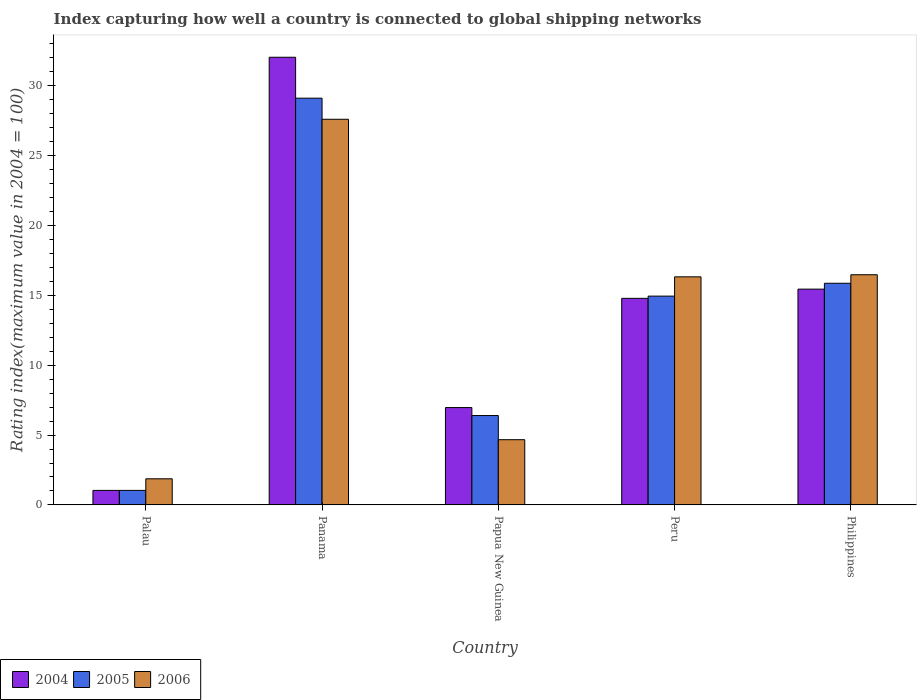How many different coloured bars are there?
Your answer should be compact. 3. How many groups of bars are there?
Give a very brief answer. 5. Are the number of bars per tick equal to the number of legend labels?
Give a very brief answer. Yes. How many bars are there on the 5th tick from the left?
Provide a short and direct response. 3. What is the label of the 1st group of bars from the left?
Provide a short and direct response. Palau. What is the rating index in 2004 in Papua New Guinea?
Make the answer very short. 6.97. Across all countries, what is the maximum rating index in 2005?
Ensure brevity in your answer.  29.12. In which country was the rating index in 2005 maximum?
Your answer should be very brief. Panama. In which country was the rating index in 2004 minimum?
Give a very brief answer. Palau. What is the total rating index in 2006 in the graph?
Give a very brief answer. 66.96. What is the difference between the rating index in 2005 in Papua New Guinea and that in Peru?
Offer a very short reply. -8.55. What is the difference between the rating index in 2005 in Panama and the rating index in 2006 in Papua New Guinea?
Ensure brevity in your answer.  24.45. What is the average rating index in 2006 per country?
Offer a very short reply. 13.39. What is the difference between the rating index of/in 2004 and rating index of/in 2005 in Philippines?
Provide a succinct answer. -0.42. What is the ratio of the rating index in 2006 in Peru to that in Philippines?
Your response must be concise. 0.99. Is the difference between the rating index in 2004 in Papua New Guinea and Philippines greater than the difference between the rating index in 2005 in Papua New Guinea and Philippines?
Give a very brief answer. Yes. What is the difference between the highest and the second highest rating index in 2006?
Provide a succinct answer. 0.15. What is the difference between the highest and the lowest rating index in 2006?
Ensure brevity in your answer.  25.74. Is the sum of the rating index in 2005 in Palau and Peru greater than the maximum rating index in 2004 across all countries?
Make the answer very short. No. What does the 3rd bar from the right in Palau represents?
Give a very brief answer. 2004. What is the difference between two consecutive major ticks on the Y-axis?
Offer a very short reply. 5. Does the graph contain grids?
Offer a terse response. No. How are the legend labels stacked?
Give a very brief answer. Horizontal. What is the title of the graph?
Provide a succinct answer. Index capturing how well a country is connected to global shipping networks. Does "1986" appear as one of the legend labels in the graph?
Your response must be concise. No. What is the label or title of the Y-axis?
Give a very brief answer. Rating index(maximum value in 2004 = 100). What is the Rating index(maximum value in 2004 = 100) in 2004 in Palau?
Offer a very short reply. 1.04. What is the Rating index(maximum value in 2004 = 100) of 2005 in Palau?
Keep it short and to the point. 1.04. What is the Rating index(maximum value in 2004 = 100) of 2006 in Palau?
Keep it short and to the point. 1.87. What is the Rating index(maximum value in 2004 = 100) of 2004 in Panama?
Keep it short and to the point. 32.05. What is the Rating index(maximum value in 2004 = 100) of 2005 in Panama?
Ensure brevity in your answer.  29.12. What is the Rating index(maximum value in 2004 = 100) in 2006 in Panama?
Ensure brevity in your answer.  27.61. What is the Rating index(maximum value in 2004 = 100) of 2004 in Papua New Guinea?
Ensure brevity in your answer.  6.97. What is the Rating index(maximum value in 2004 = 100) of 2006 in Papua New Guinea?
Your answer should be very brief. 4.67. What is the Rating index(maximum value in 2004 = 100) in 2004 in Peru?
Provide a short and direct response. 14.79. What is the Rating index(maximum value in 2004 = 100) in 2005 in Peru?
Provide a short and direct response. 14.95. What is the Rating index(maximum value in 2004 = 100) in 2006 in Peru?
Make the answer very short. 16.33. What is the Rating index(maximum value in 2004 = 100) of 2004 in Philippines?
Your answer should be compact. 15.45. What is the Rating index(maximum value in 2004 = 100) of 2005 in Philippines?
Make the answer very short. 15.87. What is the Rating index(maximum value in 2004 = 100) in 2006 in Philippines?
Offer a very short reply. 16.48. Across all countries, what is the maximum Rating index(maximum value in 2004 = 100) of 2004?
Your answer should be compact. 32.05. Across all countries, what is the maximum Rating index(maximum value in 2004 = 100) of 2005?
Ensure brevity in your answer.  29.12. Across all countries, what is the maximum Rating index(maximum value in 2004 = 100) in 2006?
Make the answer very short. 27.61. Across all countries, what is the minimum Rating index(maximum value in 2004 = 100) in 2004?
Ensure brevity in your answer.  1.04. Across all countries, what is the minimum Rating index(maximum value in 2004 = 100) of 2005?
Offer a very short reply. 1.04. Across all countries, what is the minimum Rating index(maximum value in 2004 = 100) in 2006?
Ensure brevity in your answer.  1.87. What is the total Rating index(maximum value in 2004 = 100) in 2004 in the graph?
Provide a succinct answer. 70.3. What is the total Rating index(maximum value in 2004 = 100) in 2005 in the graph?
Your answer should be very brief. 67.38. What is the total Rating index(maximum value in 2004 = 100) of 2006 in the graph?
Your answer should be very brief. 66.96. What is the difference between the Rating index(maximum value in 2004 = 100) in 2004 in Palau and that in Panama?
Ensure brevity in your answer.  -31.01. What is the difference between the Rating index(maximum value in 2004 = 100) of 2005 in Palau and that in Panama?
Offer a very short reply. -28.08. What is the difference between the Rating index(maximum value in 2004 = 100) of 2006 in Palau and that in Panama?
Provide a short and direct response. -25.74. What is the difference between the Rating index(maximum value in 2004 = 100) in 2004 in Palau and that in Papua New Guinea?
Offer a very short reply. -5.93. What is the difference between the Rating index(maximum value in 2004 = 100) in 2005 in Palau and that in Papua New Guinea?
Your response must be concise. -5.36. What is the difference between the Rating index(maximum value in 2004 = 100) of 2006 in Palau and that in Papua New Guinea?
Give a very brief answer. -2.8. What is the difference between the Rating index(maximum value in 2004 = 100) in 2004 in Palau and that in Peru?
Provide a short and direct response. -13.75. What is the difference between the Rating index(maximum value in 2004 = 100) of 2005 in Palau and that in Peru?
Ensure brevity in your answer.  -13.91. What is the difference between the Rating index(maximum value in 2004 = 100) in 2006 in Palau and that in Peru?
Offer a very short reply. -14.46. What is the difference between the Rating index(maximum value in 2004 = 100) of 2004 in Palau and that in Philippines?
Ensure brevity in your answer.  -14.41. What is the difference between the Rating index(maximum value in 2004 = 100) of 2005 in Palau and that in Philippines?
Provide a succinct answer. -14.83. What is the difference between the Rating index(maximum value in 2004 = 100) in 2006 in Palau and that in Philippines?
Provide a succinct answer. -14.61. What is the difference between the Rating index(maximum value in 2004 = 100) in 2004 in Panama and that in Papua New Guinea?
Provide a succinct answer. 25.08. What is the difference between the Rating index(maximum value in 2004 = 100) in 2005 in Panama and that in Papua New Guinea?
Offer a very short reply. 22.72. What is the difference between the Rating index(maximum value in 2004 = 100) of 2006 in Panama and that in Papua New Guinea?
Provide a short and direct response. 22.94. What is the difference between the Rating index(maximum value in 2004 = 100) in 2004 in Panama and that in Peru?
Your answer should be compact. 17.26. What is the difference between the Rating index(maximum value in 2004 = 100) in 2005 in Panama and that in Peru?
Offer a very short reply. 14.17. What is the difference between the Rating index(maximum value in 2004 = 100) of 2006 in Panama and that in Peru?
Your answer should be compact. 11.28. What is the difference between the Rating index(maximum value in 2004 = 100) of 2004 in Panama and that in Philippines?
Make the answer very short. 16.6. What is the difference between the Rating index(maximum value in 2004 = 100) of 2005 in Panama and that in Philippines?
Ensure brevity in your answer.  13.25. What is the difference between the Rating index(maximum value in 2004 = 100) in 2006 in Panama and that in Philippines?
Offer a very short reply. 11.13. What is the difference between the Rating index(maximum value in 2004 = 100) of 2004 in Papua New Guinea and that in Peru?
Ensure brevity in your answer.  -7.82. What is the difference between the Rating index(maximum value in 2004 = 100) in 2005 in Papua New Guinea and that in Peru?
Your answer should be very brief. -8.55. What is the difference between the Rating index(maximum value in 2004 = 100) in 2006 in Papua New Guinea and that in Peru?
Your answer should be very brief. -11.66. What is the difference between the Rating index(maximum value in 2004 = 100) in 2004 in Papua New Guinea and that in Philippines?
Your answer should be compact. -8.48. What is the difference between the Rating index(maximum value in 2004 = 100) in 2005 in Papua New Guinea and that in Philippines?
Keep it short and to the point. -9.47. What is the difference between the Rating index(maximum value in 2004 = 100) of 2006 in Papua New Guinea and that in Philippines?
Give a very brief answer. -11.81. What is the difference between the Rating index(maximum value in 2004 = 100) in 2004 in Peru and that in Philippines?
Make the answer very short. -0.66. What is the difference between the Rating index(maximum value in 2004 = 100) of 2005 in Peru and that in Philippines?
Offer a very short reply. -0.92. What is the difference between the Rating index(maximum value in 2004 = 100) of 2006 in Peru and that in Philippines?
Your response must be concise. -0.15. What is the difference between the Rating index(maximum value in 2004 = 100) of 2004 in Palau and the Rating index(maximum value in 2004 = 100) of 2005 in Panama?
Offer a very short reply. -28.08. What is the difference between the Rating index(maximum value in 2004 = 100) of 2004 in Palau and the Rating index(maximum value in 2004 = 100) of 2006 in Panama?
Your response must be concise. -26.57. What is the difference between the Rating index(maximum value in 2004 = 100) in 2005 in Palau and the Rating index(maximum value in 2004 = 100) in 2006 in Panama?
Your answer should be compact. -26.57. What is the difference between the Rating index(maximum value in 2004 = 100) of 2004 in Palau and the Rating index(maximum value in 2004 = 100) of 2005 in Papua New Guinea?
Keep it short and to the point. -5.36. What is the difference between the Rating index(maximum value in 2004 = 100) in 2004 in Palau and the Rating index(maximum value in 2004 = 100) in 2006 in Papua New Guinea?
Make the answer very short. -3.63. What is the difference between the Rating index(maximum value in 2004 = 100) of 2005 in Palau and the Rating index(maximum value in 2004 = 100) of 2006 in Papua New Guinea?
Your answer should be compact. -3.63. What is the difference between the Rating index(maximum value in 2004 = 100) in 2004 in Palau and the Rating index(maximum value in 2004 = 100) in 2005 in Peru?
Your answer should be compact. -13.91. What is the difference between the Rating index(maximum value in 2004 = 100) of 2004 in Palau and the Rating index(maximum value in 2004 = 100) of 2006 in Peru?
Offer a very short reply. -15.29. What is the difference between the Rating index(maximum value in 2004 = 100) in 2005 in Palau and the Rating index(maximum value in 2004 = 100) in 2006 in Peru?
Make the answer very short. -15.29. What is the difference between the Rating index(maximum value in 2004 = 100) in 2004 in Palau and the Rating index(maximum value in 2004 = 100) in 2005 in Philippines?
Provide a succinct answer. -14.83. What is the difference between the Rating index(maximum value in 2004 = 100) of 2004 in Palau and the Rating index(maximum value in 2004 = 100) of 2006 in Philippines?
Offer a terse response. -15.44. What is the difference between the Rating index(maximum value in 2004 = 100) of 2005 in Palau and the Rating index(maximum value in 2004 = 100) of 2006 in Philippines?
Your response must be concise. -15.44. What is the difference between the Rating index(maximum value in 2004 = 100) of 2004 in Panama and the Rating index(maximum value in 2004 = 100) of 2005 in Papua New Guinea?
Your response must be concise. 25.65. What is the difference between the Rating index(maximum value in 2004 = 100) in 2004 in Panama and the Rating index(maximum value in 2004 = 100) in 2006 in Papua New Guinea?
Your answer should be very brief. 27.38. What is the difference between the Rating index(maximum value in 2004 = 100) of 2005 in Panama and the Rating index(maximum value in 2004 = 100) of 2006 in Papua New Guinea?
Provide a succinct answer. 24.45. What is the difference between the Rating index(maximum value in 2004 = 100) of 2004 in Panama and the Rating index(maximum value in 2004 = 100) of 2005 in Peru?
Your answer should be very brief. 17.1. What is the difference between the Rating index(maximum value in 2004 = 100) in 2004 in Panama and the Rating index(maximum value in 2004 = 100) in 2006 in Peru?
Your response must be concise. 15.72. What is the difference between the Rating index(maximum value in 2004 = 100) of 2005 in Panama and the Rating index(maximum value in 2004 = 100) of 2006 in Peru?
Offer a terse response. 12.79. What is the difference between the Rating index(maximum value in 2004 = 100) in 2004 in Panama and the Rating index(maximum value in 2004 = 100) in 2005 in Philippines?
Make the answer very short. 16.18. What is the difference between the Rating index(maximum value in 2004 = 100) in 2004 in Panama and the Rating index(maximum value in 2004 = 100) in 2006 in Philippines?
Give a very brief answer. 15.57. What is the difference between the Rating index(maximum value in 2004 = 100) of 2005 in Panama and the Rating index(maximum value in 2004 = 100) of 2006 in Philippines?
Your answer should be compact. 12.64. What is the difference between the Rating index(maximum value in 2004 = 100) of 2004 in Papua New Guinea and the Rating index(maximum value in 2004 = 100) of 2005 in Peru?
Offer a very short reply. -7.98. What is the difference between the Rating index(maximum value in 2004 = 100) of 2004 in Papua New Guinea and the Rating index(maximum value in 2004 = 100) of 2006 in Peru?
Your response must be concise. -9.36. What is the difference between the Rating index(maximum value in 2004 = 100) of 2005 in Papua New Guinea and the Rating index(maximum value in 2004 = 100) of 2006 in Peru?
Make the answer very short. -9.93. What is the difference between the Rating index(maximum value in 2004 = 100) in 2004 in Papua New Guinea and the Rating index(maximum value in 2004 = 100) in 2006 in Philippines?
Your response must be concise. -9.51. What is the difference between the Rating index(maximum value in 2004 = 100) of 2005 in Papua New Guinea and the Rating index(maximum value in 2004 = 100) of 2006 in Philippines?
Give a very brief answer. -10.08. What is the difference between the Rating index(maximum value in 2004 = 100) of 2004 in Peru and the Rating index(maximum value in 2004 = 100) of 2005 in Philippines?
Provide a short and direct response. -1.08. What is the difference between the Rating index(maximum value in 2004 = 100) of 2004 in Peru and the Rating index(maximum value in 2004 = 100) of 2006 in Philippines?
Provide a short and direct response. -1.69. What is the difference between the Rating index(maximum value in 2004 = 100) of 2005 in Peru and the Rating index(maximum value in 2004 = 100) of 2006 in Philippines?
Provide a succinct answer. -1.53. What is the average Rating index(maximum value in 2004 = 100) in 2004 per country?
Provide a short and direct response. 14.06. What is the average Rating index(maximum value in 2004 = 100) of 2005 per country?
Keep it short and to the point. 13.48. What is the average Rating index(maximum value in 2004 = 100) of 2006 per country?
Keep it short and to the point. 13.39. What is the difference between the Rating index(maximum value in 2004 = 100) in 2004 and Rating index(maximum value in 2004 = 100) in 2006 in Palau?
Offer a terse response. -0.83. What is the difference between the Rating index(maximum value in 2004 = 100) in 2005 and Rating index(maximum value in 2004 = 100) in 2006 in Palau?
Your answer should be very brief. -0.83. What is the difference between the Rating index(maximum value in 2004 = 100) of 2004 and Rating index(maximum value in 2004 = 100) of 2005 in Panama?
Give a very brief answer. 2.93. What is the difference between the Rating index(maximum value in 2004 = 100) in 2004 and Rating index(maximum value in 2004 = 100) in 2006 in Panama?
Provide a short and direct response. 4.44. What is the difference between the Rating index(maximum value in 2004 = 100) in 2005 and Rating index(maximum value in 2004 = 100) in 2006 in Panama?
Offer a very short reply. 1.51. What is the difference between the Rating index(maximum value in 2004 = 100) of 2004 and Rating index(maximum value in 2004 = 100) of 2005 in Papua New Guinea?
Provide a succinct answer. 0.57. What is the difference between the Rating index(maximum value in 2004 = 100) in 2005 and Rating index(maximum value in 2004 = 100) in 2006 in Papua New Guinea?
Ensure brevity in your answer.  1.73. What is the difference between the Rating index(maximum value in 2004 = 100) of 2004 and Rating index(maximum value in 2004 = 100) of 2005 in Peru?
Your answer should be very brief. -0.16. What is the difference between the Rating index(maximum value in 2004 = 100) in 2004 and Rating index(maximum value in 2004 = 100) in 2006 in Peru?
Ensure brevity in your answer.  -1.54. What is the difference between the Rating index(maximum value in 2004 = 100) of 2005 and Rating index(maximum value in 2004 = 100) of 2006 in Peru?
Your answer should be compact. -1.38. What is the difference between the Rating index(maximum value in 2004 = 100) in 2004 and Rating index(maximum value in 2004 = 100) in 2005 in Philippines?
Make the answer very short. -0.42. What is the difference between the Rating index(maximum value in 2004 = 100) of 2004 and Rating index(maximum value in 2004 = 100) of 2006 in Philippines?
Offer a terse response. -1.03. What is the difference between the Rating index(maximum value in 2004 = 100) in 2005 and Rating index(maximum value in 2004 = 100) in 2006 in Philippines?
Provide a succinct answer. -0.61. What is the ratio of the Rating index(maximum value in 2004 = 100) of 2004 in Palau to that in Panama?
Offer a very short reply. 0.03. What is the ratio of the Rating index(maximum value in 2004 = 100) of 2005 in Palau to that in Panama?
Your answer should be compact. 0.04. What is the ratio of the Rating index(maximum value in 2004 = 100) of 2006 in Palau to that in Panama?
Provide a succinct answer. 0.07. What is the ratio of the Rating index(maximum value in 2004 = 100) in 2004 in Palau to that in Papua New Guinea?
Your answer should be compact. 0.15. What is the ratio of the Rating index(maximum value in 2004 = 100) of 2005 in Palau to that in Papua New Guinea?
Your answer should be compact. 0.16. What is the ratio of the Rating index(maximum value in 2004 = 100) in 2006 in Palau to that in Papua New Guinea?
Your answer should be compact. 0.4. What is the ratio of the Rating index(maximum value in 2004 = 100) of 2004 in Palau to that in Peru?
Provide a succinct answer. 0.07. What is the ratio of the Rating index(maximum value in 2004 = 100) in 2005 in Palau to that in Peru?
Provide a short and direct response. 0.07. What is the ratio of the Rating index(maximum value in 2004 = 100) of 2006 in Palau to that in Peru?
Your answer should be very brief. 0.11. What is the ratio of the Rating index(maximum value in 2004 = 100) in 2004 in Palau to that in Philippines?
Your response must be concise. 0.07. What is the ratio of the Rating index(maximum value in 2004 = 100) in 2005 in Palau to that in Philippines?
Keep it short and to the point. 0.07. What is the ratio of the Rating index(maximum value in 2004 = 100) in 2006 in Palau to that in Philippines?
Provide a short and direct response. 0.11. What is the ratio of the Rating index(maximum value in 2004 = 100) in 2004 in Panama to that in Papua New Guinea?
Offer a very short reply. 4.6. What is the ratio of the Rating index(maximum value in 2004 = 100) of 2005 in Panama to that in Papua New Guinea?
Keep it short and to the point. 4.55. What is the ratio of the Rating index(maximum value in 2004 = 100) of 2006 in Panama to that in Papua New Guinea?
Offer a terse response. 5.91. What is the ratio of the Rating index(maximum value in 2004 = 100) in 2004 in Panama to that in Peru?
Your response must be concise. 2.17. What is the ratio of the Rating index(maximum value in 2004 = 100) in 2005 in Panama to that in Peru?
Give a very brief answer. 1.95. What is the ratio of the Rating index(maximum value in 2004 = 100) of 2006 in Panama to that in Peru?
Offer a very short reply. 1.69. What is the ratio of the Rating index(maximum value in 2004 = 100) of 2004 in Panama to that in Philippines?
Make the answer very short. 2.07. What is the ratio of the Rating index(maximum value in 2004 = 100) in 2005 in Panama to that in Philippines?
Your response must be concise. 1.83. What is the ratio of the Rating index(maximum value in 2004 = 100) of 2006 in Panama to that in Philippines?
Provide a succinct answer. 1.68. What is the ratio of the Rating index(maximum value in 2004 = 100) in 2004 in Papua New Guinea to that in Peru?
Your response must be concise. 0.47. What is the ratio of the Rating index(maximum value in 2004 = 100) of 2005 in Papua New Guinea to that in Peru?
Provide a short and direct response. 0.43. What is the ratio of the Rating index(maximum value in 2004 = 100) of 2006 in Papua New Guinea to that in Peru?
Provide a short and direct response. 0.29. What is the ratio of the Rating index(maximum value in 2004 = 100) of 2004 in Papua New Guinea to that in Philippines?
Provide a succinct answer. 0.45. What is the ratio of the Rating index(maximum value in 2004 = 100) of 2005 in Papua New Guinea to that in Philippines?
Offer a terse response. 0.4. What is the ratio of the Rating index(maximum value in 2004 = 100) in 2006 in Papua New Guinea to that in Philippines?
Your answer should be very brief. 0.28. What is the ratio of the Rating index(maximum value in 2004 = 100) in 2004 in Peru to that in Philippines?
Provide a succinct answer. 0.96. What is the ratio of the Rating index(maximum value in 2004 = 100) in 2005 in Peru to that in Philippines?
Give a very brief answer. 0.94. What is the ratio of the Rating index(maximum value in 2004 = 100) in 2006 in Peru to that in Philippines?
Your response must be concise. 0.99. What is the difference between the highest and the second highest Rating index(maximum value in 2004 = 100) of 2005?
Offer a terse response. 13.25. What is the difference between the highest and the second highest Rating index(maximum value in 2004 = 100) in 2006?
Give a very brief answer. 11.13. What is the difference between the highest and the lowest Rating index(maximum value in 2004 = 100) of 2004?
Give a very brief answer. 31.01. What is the difference between the highest and the lowest Rating index(maximum value in 2004 = 100) of 2005?
Offer a very short reply. 28.08. What is the difference between the highest and the lowest Rating index(maximum value in 2004 = 100) of 2006?
Offer a terse response. 25.74. 